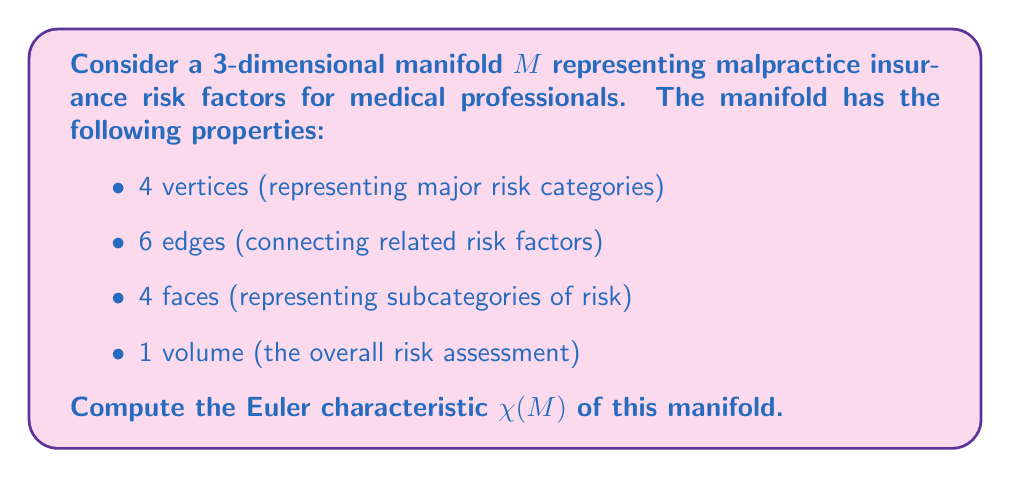Can you answer this question? To solve this problem, we'll use the generalized Euler characteristic formula for a 3-dimensional manifold:

$$\chi(M) = V - E + F - C$$

Where:
$V$ = number of vertices
$E$ = number of edges
$F$ = number of faces
$C$ = number of 3-dimensional cells (volumes)

Given:
$V = 4$
$E = 6$
$F = 4$
$C = 1$

Let's substitute these values into the formula:

$$\chi(M) = 4 - 6 + 4 - 1$$

Now, we can simplify:

$$\chi(M) = 8 - 7 = 1$$

The Euler characteristic of this manifold is 1, which is interesting from a topological perspective. This result suggests that the manifold has the same topological properties as a 3-dimensional ball or a point, indicating a relatively simple overall structure of the malpractice insurance risk factors despite the various subcategories and connections between them.

For a medical negligence lawyer transitioning careers, this result might suggest that while the risk factors seem complex on the surface, the underlying structure of malpractice insurance risks is fundamentally simple and cohesive.
Answer: $\chi(M) = 1$ 